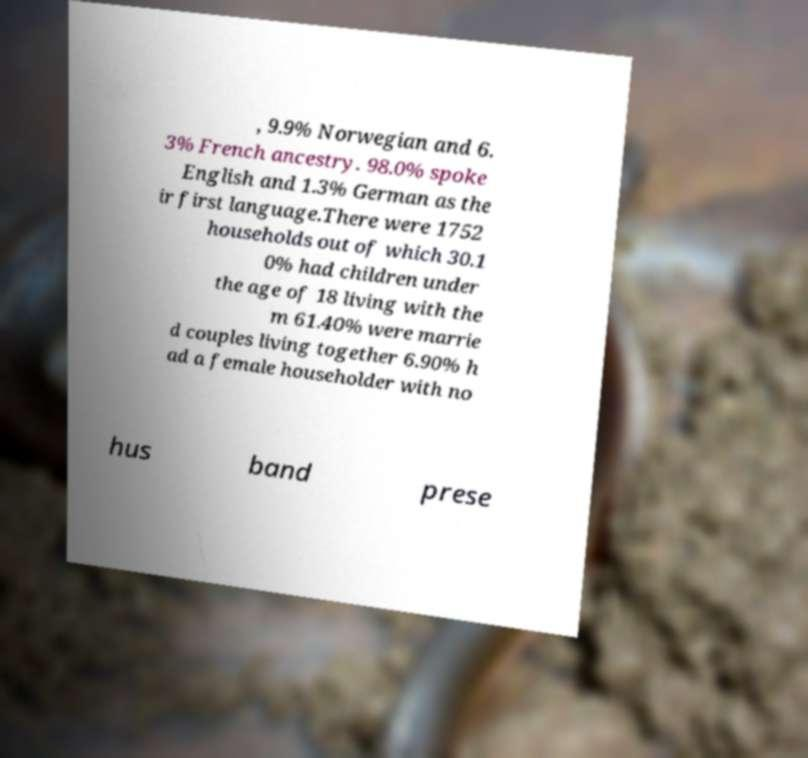For documentation purposes, I need the text within this image transcribed. Could you provide that? , 9.9% Norwegian and 6. 3% French ancestry. 98.0% spoke English and 1.3% German as the ir first language.There were 1752 households out of which 30.1 0% had children under the age of 18 living with the m 61.40% were marrie d couples living together 6.90% h ad a female householder with no hus band prese 